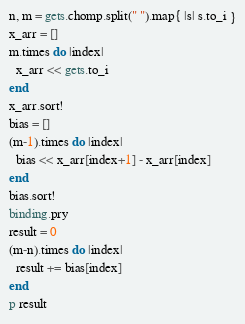<code> <loc_0><loc_0><loc_500><loc_500><_Ruby_>n, m = gets.chomp.split(" ").map{ |s| s.to_i }
x_arr = []
m.times do |index|
  x_arr << gets.to_i
end
x_arr.sort!
bias = []
(m-1).times do |index|
  bias << x_arr[index+1] - x_arr[index]
end
bias.sort!
binding.pry
result = 0
(m-n).times do |index|
  result += bias[index]
end
p result</code> 